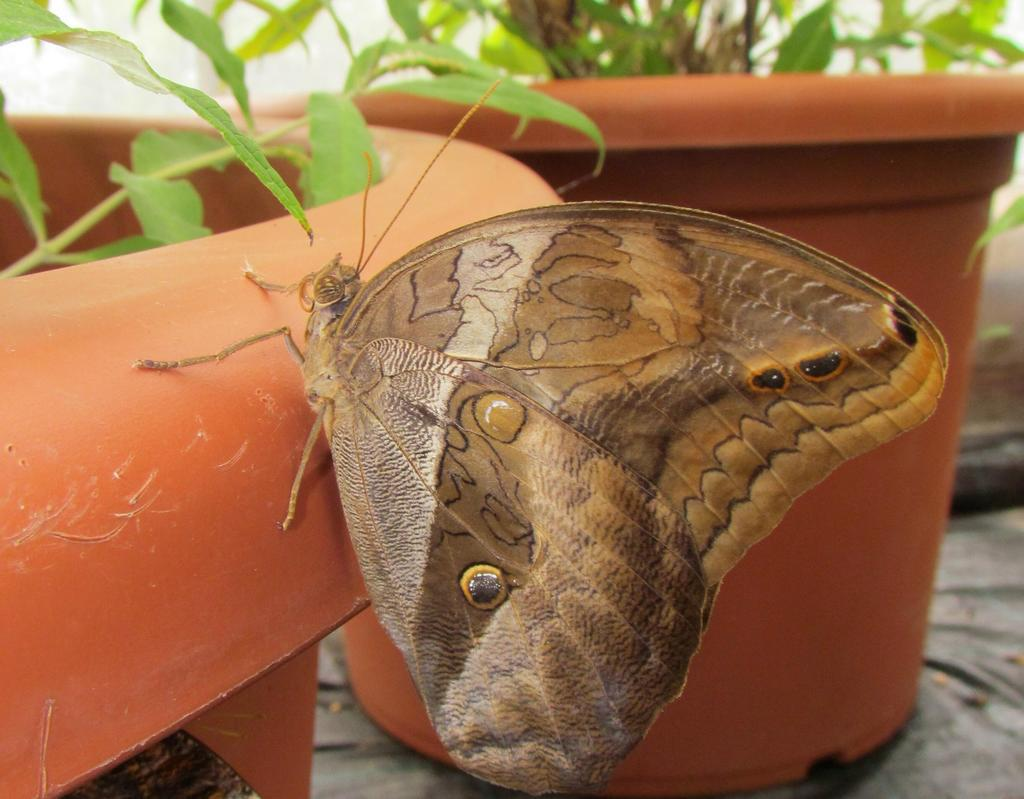What type of animal can be seen in the image? There is a butterfly in the image. What can be seen in the background of the image? There are plant pots in the background of the image. What type of trousers is the butterfly wearing in the image? Butterflies do not wear trousers, as they are insects and do not have clothing. 